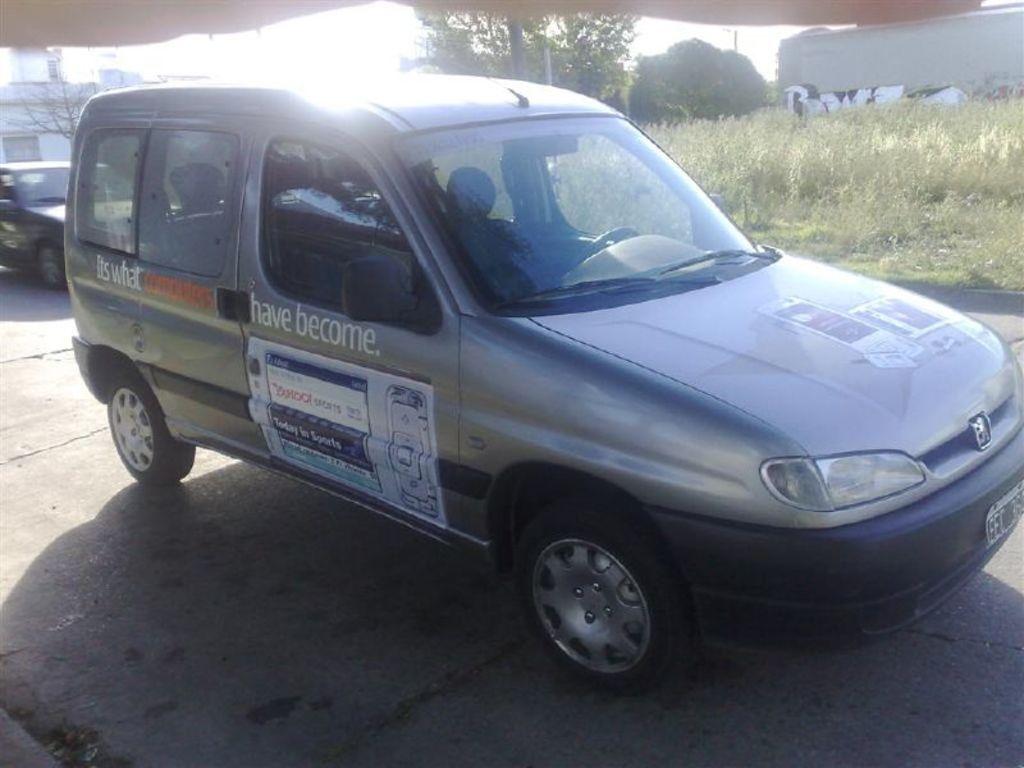What is white text on the passenger door?
Provide a short and direct response. Have become. Is the car advertising yahoo?
Make the answer very short. Yes. 